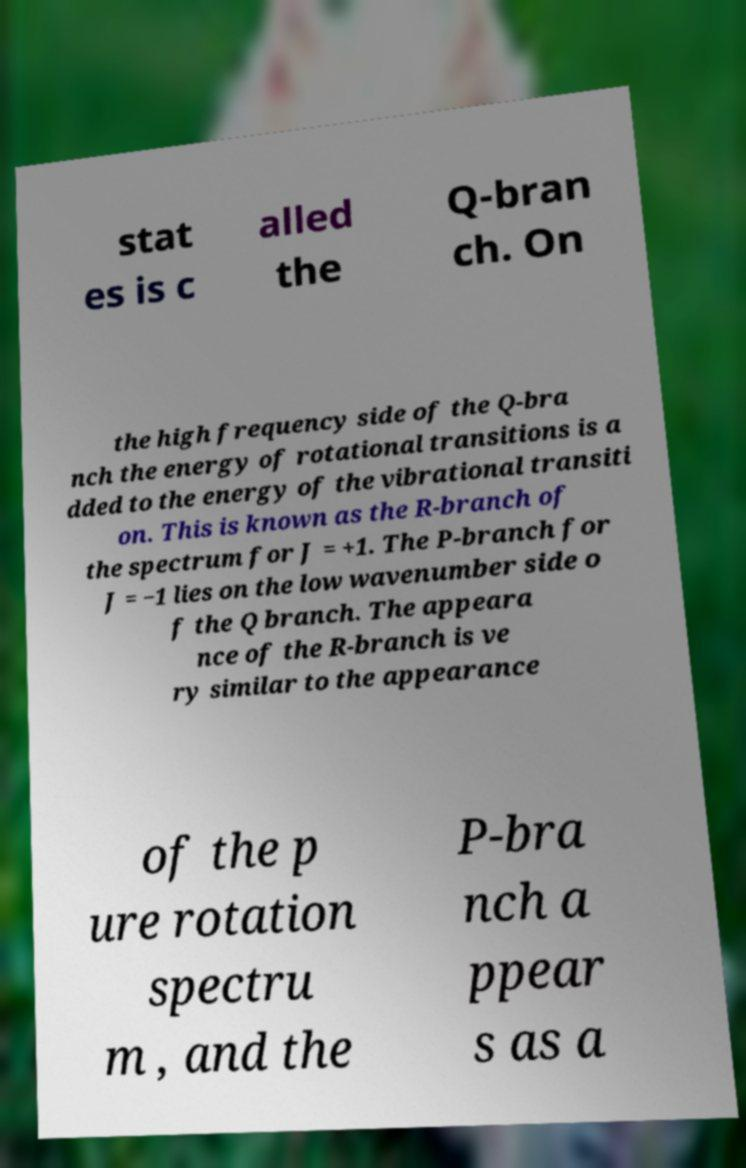I need the written content from this picture converted into text. Can you do that? stat es is c alled the Q-bran ch. On the high frequency side of the Q-bra nch the energy of rotational transitions is a dded to the energy of the vibrational transiti on. This is known as the R-branch of the spectrum for J = +1. The P-branch for J = −1 lies on the low wavenumber side o f the Q branch. The appeara nce of the R-branch is ve ry similar to the appearance of the p ure rotation spectru m , and the P-bra nch a ppear s as a 